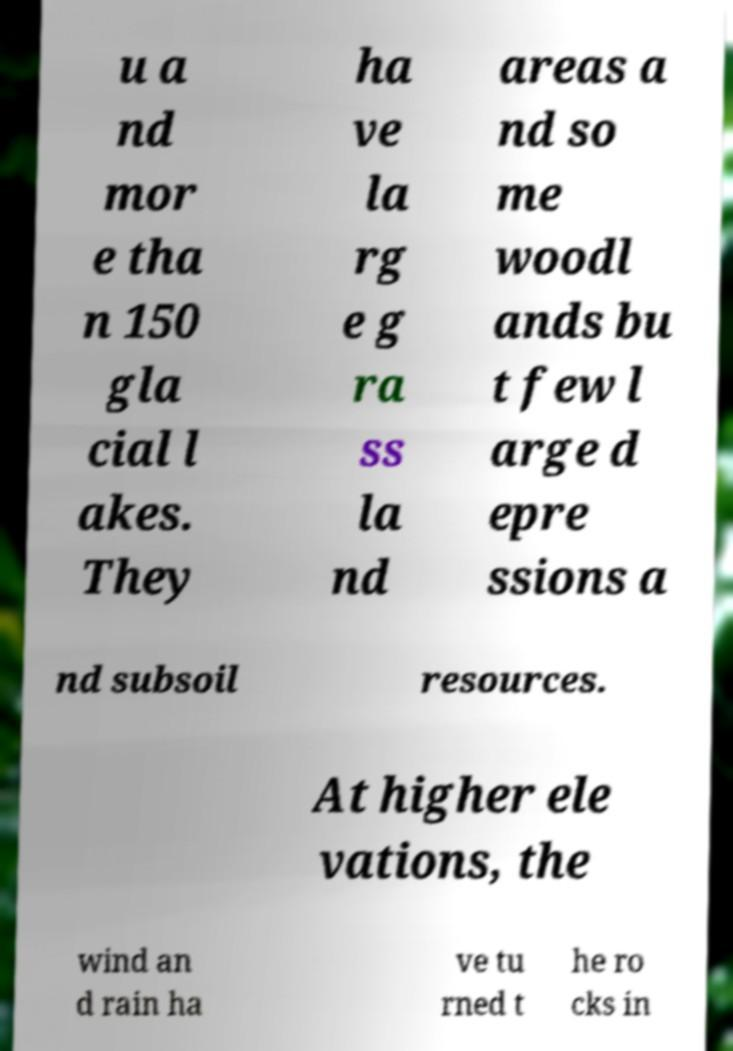Please read and relay the text visible in this image. What does it say? u a nd mor e tha n 150 gla cial l akes. They ha ve la rg e g ra ss la nd areas a nd so me woodl ands bu t few l arge d epre ssions a nd subsoil resources. At higher ele vations, the wind an d rain ha ve tu rned t he ro cks in 